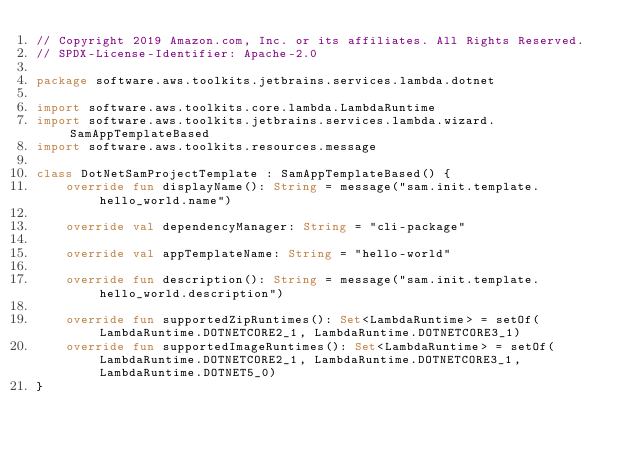<code> <loc_0><loc_0><loc_500><loc_500><_Kotlin_>// Copyright 2019 Amazon.com, Inc. or its affiliates. All Rights Reserved.
// SPDX-License-Identifier: Apache-2.0

package software.aws.toolkits.jetbrains.services.lambda.dotnet

import software.aws.toolkits.core.lambda.LambdaRuntime
import software.aws.toolkits.jetbrains.services.lambda.wizard.SamAppTemplateBased
import software.aws.toolkits.resources.message

class DotNetSamProjectTemplate : SamAppTemplateBased() {
    override fun displayName(): String = message("sam.init.template.hello_world.name")

    override val dependencyManager: String = "cli-package"

    override val appTemplateName: String = "hello-world"

    override fun description(): String = message("sam.init.template.hello_world.description")

    override fun supportedZipRuntimes(): Set<LambdaRuntime> = setOf(LambdaRuntime.DOTNETCORE2_1, LambdaRuntime.DOTNETCORE3_1)
    override fun supportedImageRuntimes(): Set<LambdaRuntime> = setOf(LambdaRuntime.DOTNETCORE2_1, LambdaRuntime.DOTNETCORE3_1, LambdaRuntime.DOTNET5_0)
}
</code> 